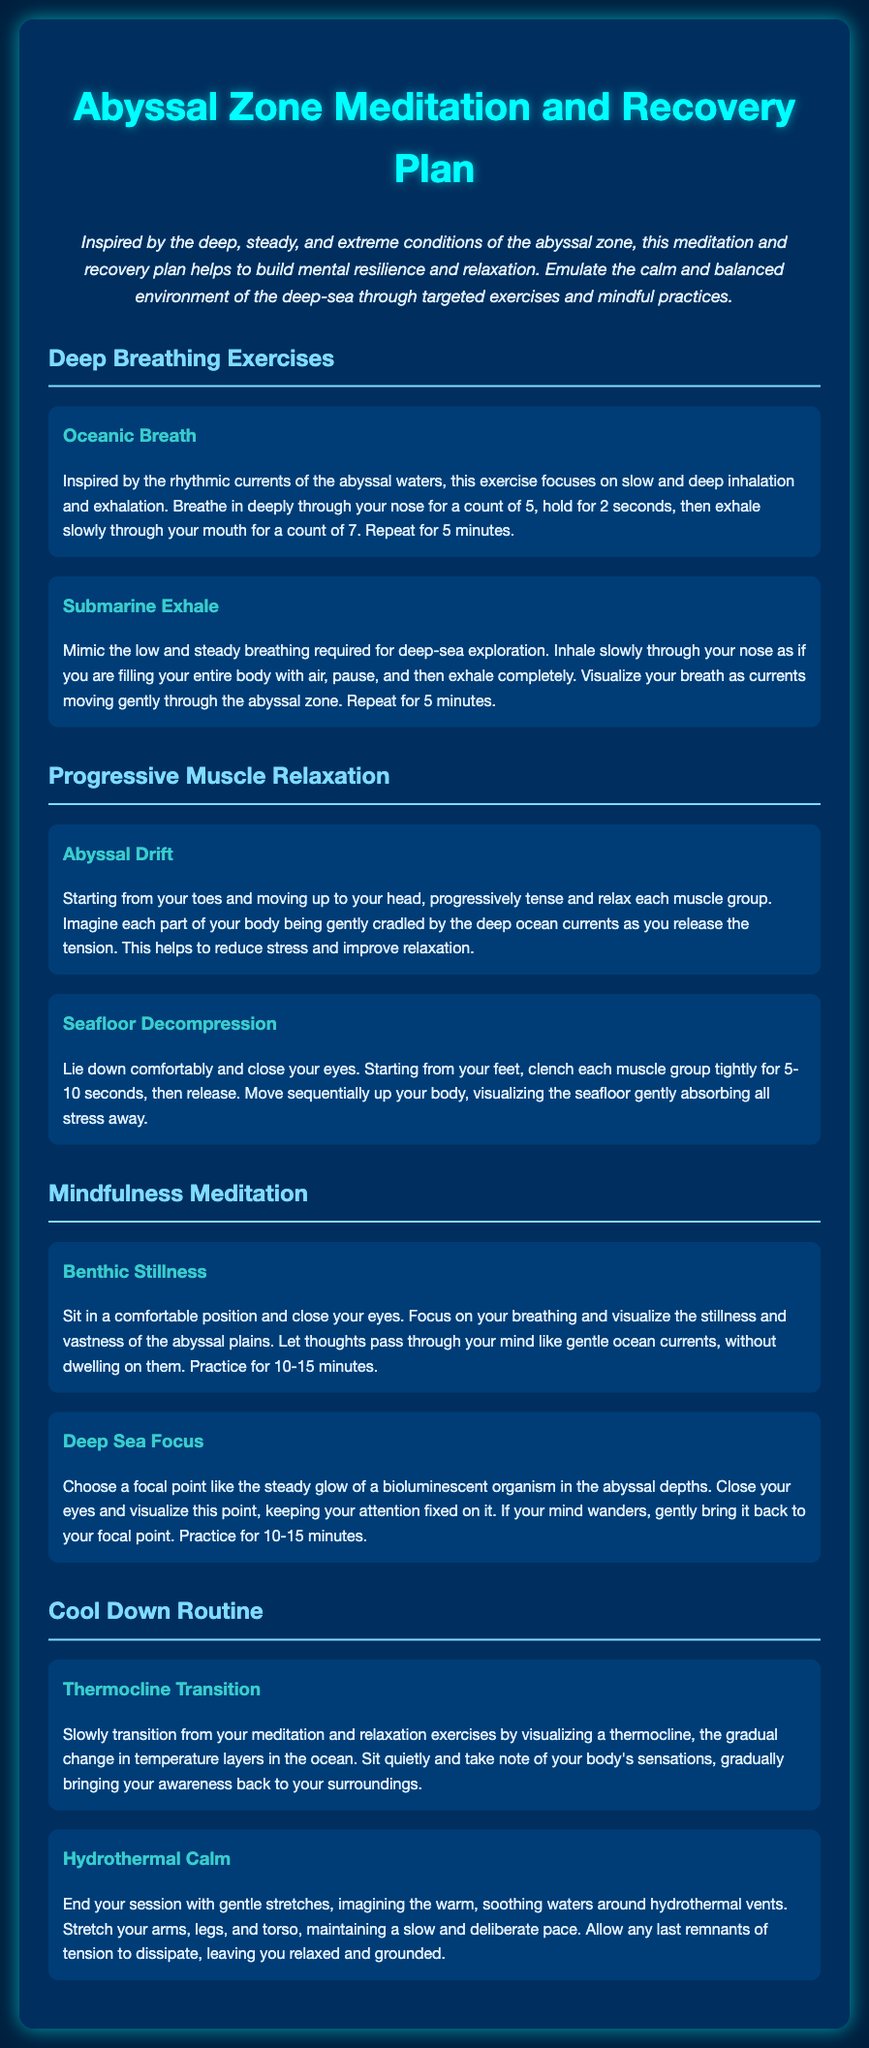What is the title of the document? The title of the document is mentioned at the top, indicating the focus on meditation and recovery inspired by a specific environment.
Answer: Abyssal Zone Meditation and Recovery Plan What is the main color scheme of the document? The main colors in the document include deep blues and contrasting light colors that evoke the abyssal zone.
Answer: Deep blue and light colors How long should you practice the Oceanic Breath exercise? The duration for this exercise is explicitly mentioned in the description of the exercise.
Answer: 5 minutes What is the focus of the Abyssal Drift exercise? This exercise focuses on muscle relaxation, progressing from one body part to another, while picturing a soothing environment.
Answer: Progressive muscle relaxation What is the purpose of the Mindfulness Meditation section? The section aims to enhance mental resilience and relaxation through focused breathing and visualization techniques in a quiet environment.
Answer: Mental resilience and relaxation How many breathing exercises are listed in the document? The document contains two exercises explicitly under the deep breathing category.
Answer: Two What imagery is suggested for the Deep Sea Focus exercise? The exercise suggests visualizing a specific organism to maintain focus and concentration.
Answer: Bioluminescent organism What type of routine follows the meditation and relaxation exercises? The document outlines a specific routine to help transition back to awareness after meditation.
Answer: Cool Down Routine 